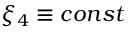<formula> <loc_0><loc_0><loc_500><loc_500>\xi _ { 4 } \equiv c o n s t</formula> 